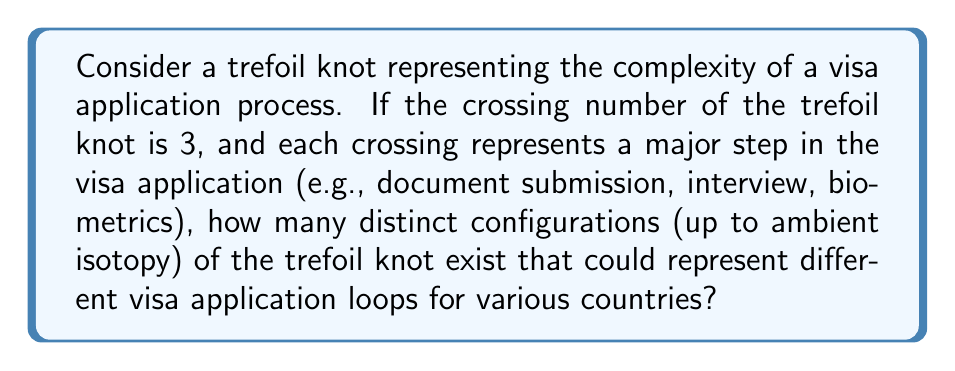Solve this math problem. To solve this problem, we need to consider the properties of the trefoil knot in relation to visa application loops:

1. The trefoil knot is the simplest non-trivial knot, with a crossing number of 3.

2. In knot theory, ambient isotopy is a way of deforming a knot without cutting or passing it through itself. This is analogous to different countries having similar visa processes but with slight variations.

3. The trefoil knot has a property called chirality, meaning it comes in two distinct forms: left-handed and right-handed. These are not ambient isotopic to each other.

4. The number of distinct configurations of the trefoil knot up to ambient isotopy is determined by its chirality.

5. For each chiral form (left-handed and right-handed), there is only one distinct configuration up to ambient isotopy.

Therefore, the number of distinct configurations of the trefoil knot that could represent different visa application loops is:

$$ \text{Number of configurations} = \text{Number of chiral forms} = 2 $$

This means there are two fundamentally different ways the visa application process (represented by the trefoil knot) can be structured, which could correspond to significantly different approaches taken by various countries.
Answer: 2 